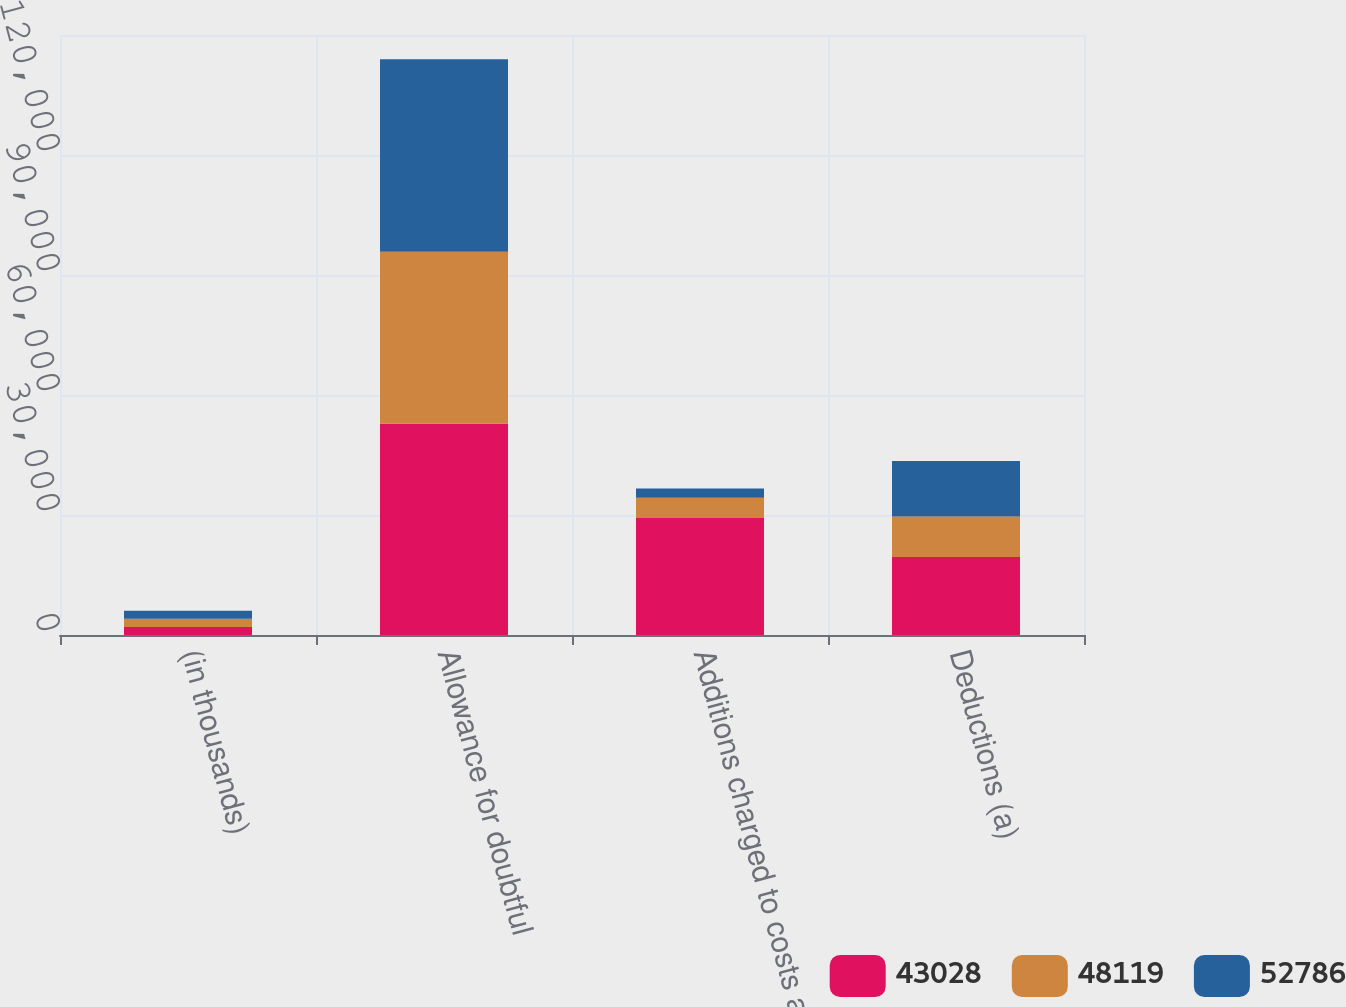<chart> <loc_0><loc_0><loc_500><loc_500><stacked_bar_chart><ecel><fcel>(in thousands)<fcel>Allowance for doubtful<fcel>Additions charged to costs and<fcel>Deductions (a)<nl><fcel>43028<fcel>2017<fcel>52786<fcel>29248<fcel>19490<nl><fcel>48119<fcel>2016<fcel>43028<fcel>5060<fcel>10151<nl><fcel>52786<fcel>2015<fcel>48119<fcel>2317<fcel>13888<nl></chart> 